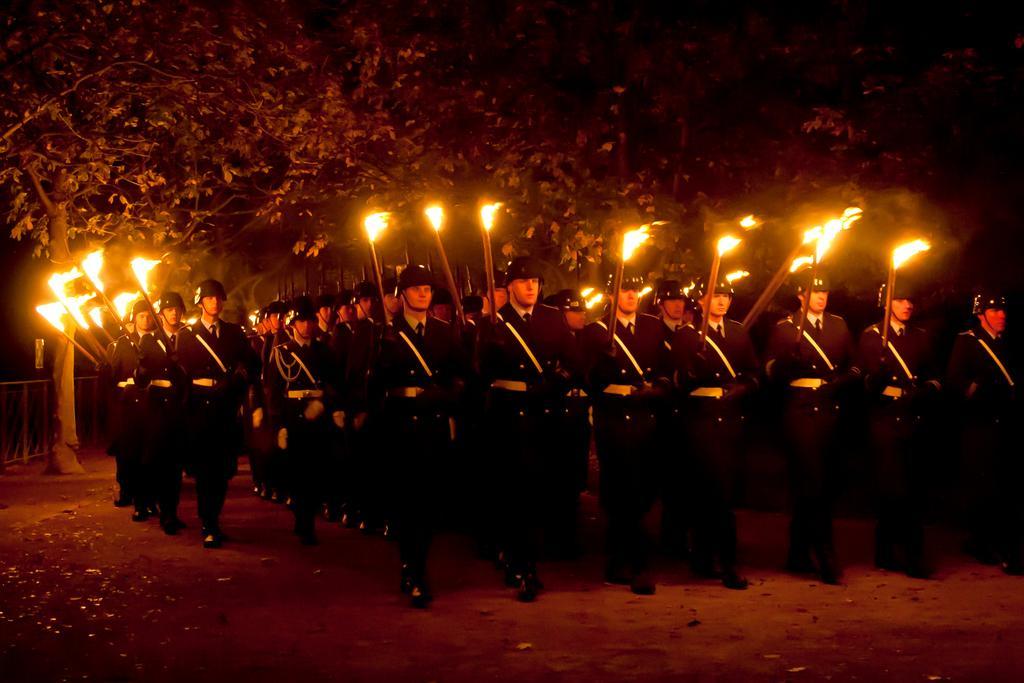How would you summarize this image in a sentence or two? In the foreground of this image, there is the crowd of men standing and holding the fire sticks in their hands are walking on the ground. In the background, there are trees. 